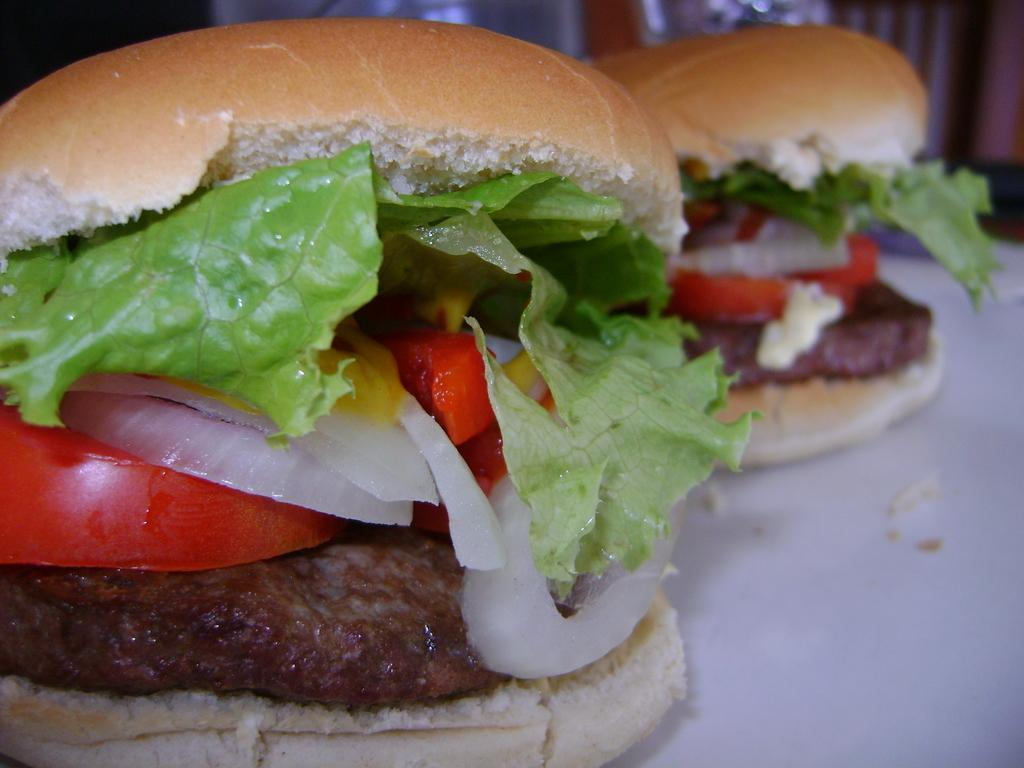What is on the white surface in the image? There are two burgers on a white surface. What can be found inside the burgers? The burgers have veggies. Can you describe the background of the image? The background is blurred. How many jellyfish are swimming in the background of the image? There are no jellyfish present in the image; the background is blurred. What type of crate is holding the burgers in the image? There is no crate present in the image; the burgers are on a white surface. 